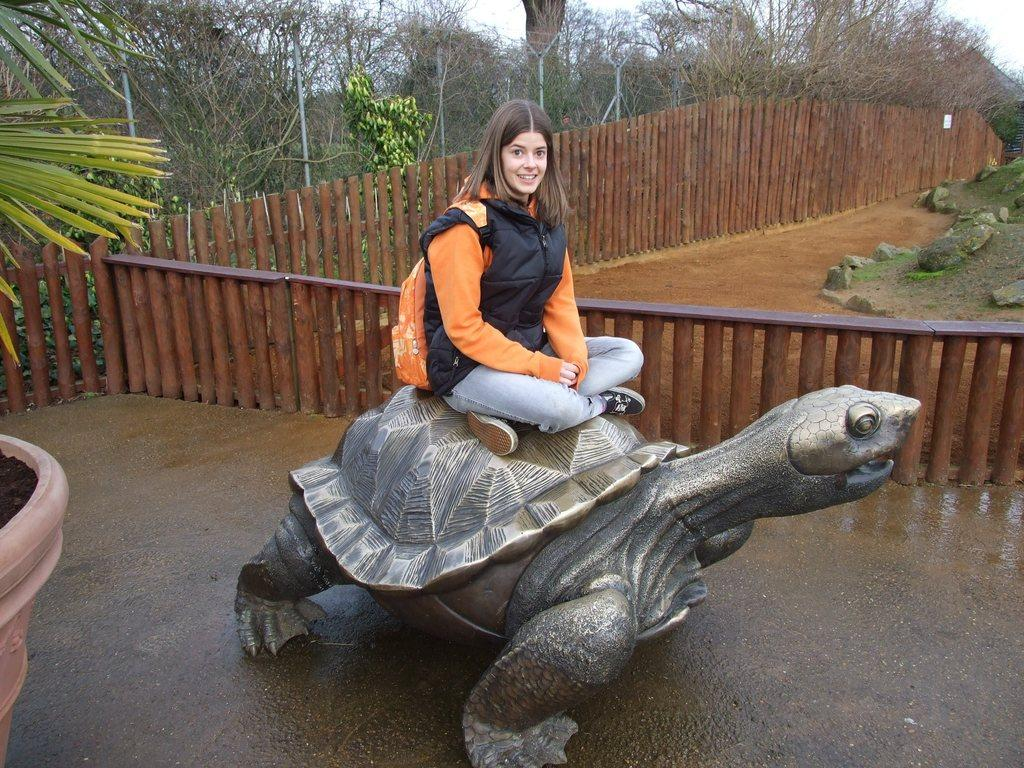What is the woman doing in the image? The woman is sitting on a tortoise statue in the image. What can be seen in the background of the image? There is a wooden fence and trees in the image. What is visible above the fence and trees? The sky is visible in the image. What type of lumber is being used to build the tortoise statue in the image? There is no information about the type of lumber used to build the tortoise statue, as it is a statue and not a real tortoise. 